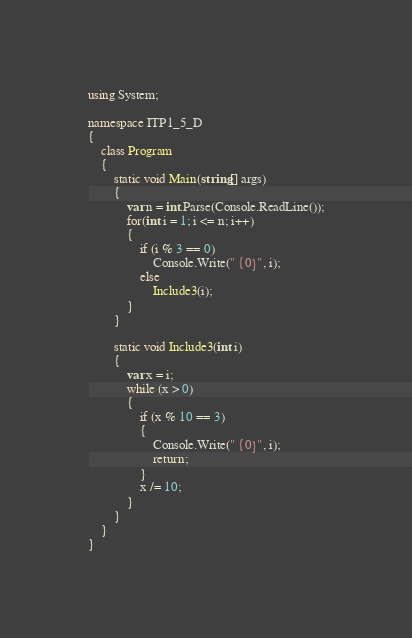Convert code to text. <code><loc_0><loc_0><loc_500><loc_500><_C#_>using System;

namespace ITP1_5_D
{
    class Program
    {
        static void Main(string[] args)
        {
            var n = int.Parse(Console.ReadLine());
            for(int i = 1; i <= n; i++)
            {
                if (i % 3 == 0)
                    Console.Write(" {0}", i);
                else
                    Include3(i);
            }
        }

        static void Include3(int i)
        {
            var x = i;
            while (x > 0)
            {
                if (x % 10 == 3)
                {
                    Console.Write(" {0}", i);
                    return;
                }
                x /= 10;
            }
        }
    }
}</code> 